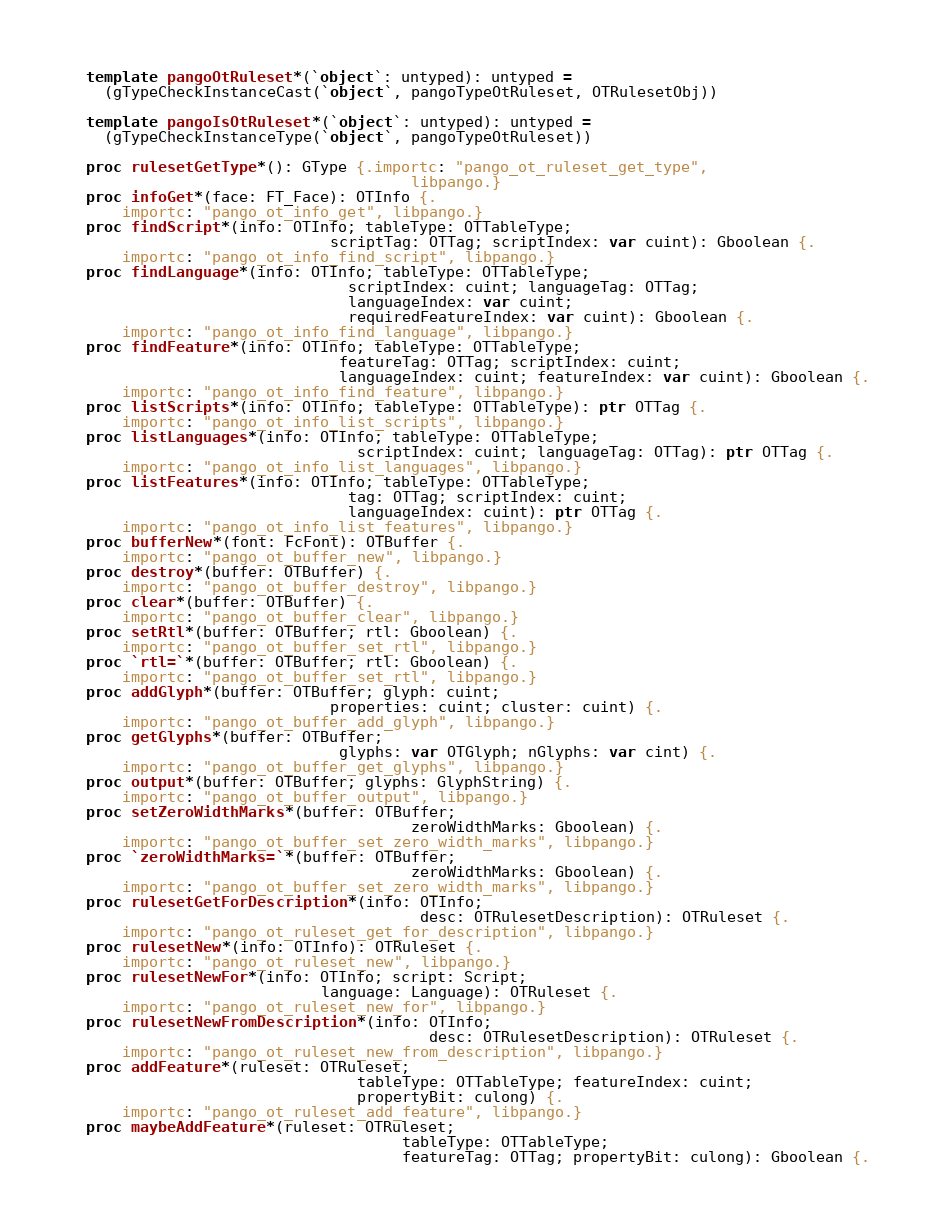<code> <loc_0><loc_0><loc_500><loc_500><_Nim_>  template pangoOtRuleset*(`object`: untyped): untyped =
    (gTypeCheckInstanceCast(`object`, pangoTypeOtRuleset, OTRulesetObj))

  template pangoIsOtRuleset*(`object`: untyped): untyped =
    (gTypeCheckInstanceType(`object`, pangoTypeOtRuleset))

  proc rulesetGetType*(): GType {.importc: "pango_ot_ruleset_get_type",
                                      libpango.}
  proc infoGet*(face: FT_Face): OTInfo {.
      importc: "pango_ot_info_get", libpango.}
  proc findScript*(info: OTInfo; tableType: OTTableType;
                             scriptTag: OTTag; scriptIndex: var cuint): Gboolean {.
      importc: "pango_ot_info_find_script", libpango.}
  proc findLanguage*(info: OTInfo; tableType: OTTableType;
                               scriptIndex: cuint; languageTag: OTTag;
                               languageIndex: var cuint;
                               requiredFeatureIndex: var cuint): Gboolean {.
      importc: "pango_ot_info_find_language", libpango.}
  proc findFeature*(info: OTInfo; tableType: OTTableType;
                              featureTag: OTTag; scriptIndex: cuint;
                              languageIndex: cuint; featureIndex: var cuint): Gboolean {.
      importc: "pango_ot_info_find_feature", libpango.}
  proc listScripts*(info: OTInfo; tableType: OTTableType): ptr OTTag {.
      importc: "pango_ot_info_list_scripts", libpango.}
  proc listLanguages*(info: OTInfo; tableType: OTTableType;
                                scriptIndex: cuint; languageTag: OTTag): ptr OTTag {.
      importc: "pango_ot_info_list_languages", libpango.}
  proc listFeatures*(info: OTInfo; tableType: OTTableType;
                               tag: OTTag; scriptIndex: cuint;
                               languageIndex: cuint): ptr OTTag {.
      importc: "pango_ot_info_list_features", libpango.}
  proc bufferNew*(font: FcFont): OTBuffer {.
      importc: "pango_ot_buffer_new", libpango.}
  proc destroy*(buffer: OTBuffer) {.
      importc: "pango_ot_buffer_destroy", libpango.}
  proc clear*(buffer: OTBuffer) {.
      importc: "pango_ot_buffer_clear", libpango.}
  proc setRtl*(buffer: OTBuffer; rtl: Gboolean) {.
      importc: "pango_ot_buffer_set_rtl", libpango.}
  proc `rtl=`*(buffer: OTBuffer; rtl: Gboolean) {.
      importc: "pango_ot_buffer_set_rtl", libpango.}
  proc addGlyph*(buffer: OTBuffer; glyph: cuint;
                             properties: cuint; cluster: cuint) {.
      importc: "pango_ot_buffer_add_glyph", libpango.}
  proc getGlyphs*(buffer: OTBuffer;
                              glyphs: var OTGlyph; nGlyphs: var cint) {.
      importc: "pango_ot_buffer_get_glyphs", libpango.}
  proc output*(buffer: OTBuffer; glyphs: GlyphString) {.
      importc: "pango_ot_buffer_output", libpango.}
  proc setZeroWidthMarks*(buffer: OTBuffer;
                                      zeroWidthMarks: Gboolean) {.
      importc: "pango_ot_buffer_set_zero_width_marks", libpango.}
  proc `zeroWidthMarks=`*(buffer: OTBuffer;
                                      zeroWidthMarks: Gboolean) {.
      importc: "pango_ot_buffer_set_zero_width_marks", libpango.}
  proc rulesetGetForDescription*(info: OTInfo;
                                       desc: OTRulesetDescription): OTRuleset {.
      importc: "pango_ot_ruleset_get_for_description", libpango.}
  proc rulesetNew*(info: OTInfo): OTRuleset {.
      importc: "pango_ot_ruleset_new", libpango.}
  proc rulesetNewFor*(info: OTInfo; script: Script;
                            language: Language): OTRuleset {.
      importc: "pango_ot_ruleset_new_for", libpango.}
  proc rulesetNewFromDescription*(info: OTInfo;
                                        desc: OTRulesetDescription): OTRuleset {.
      importc: "pango_ot_ruleset_new_from_description", libpango.}
  proc addFeature*(ruleset: OTRuleset;
                                tableType: OTTableType; featureIndex: cuint;
                                propertyBit: culong) {.
      importc: "pango_ot_ruleset_add_feature", libpango.}
  proc maybeAddFeature*(ruleset: OTRuleset;
                                     tableType: OTTableType;
                                     featureTag: OTTag; propertyBit: culong): Gboolean {.</code> 